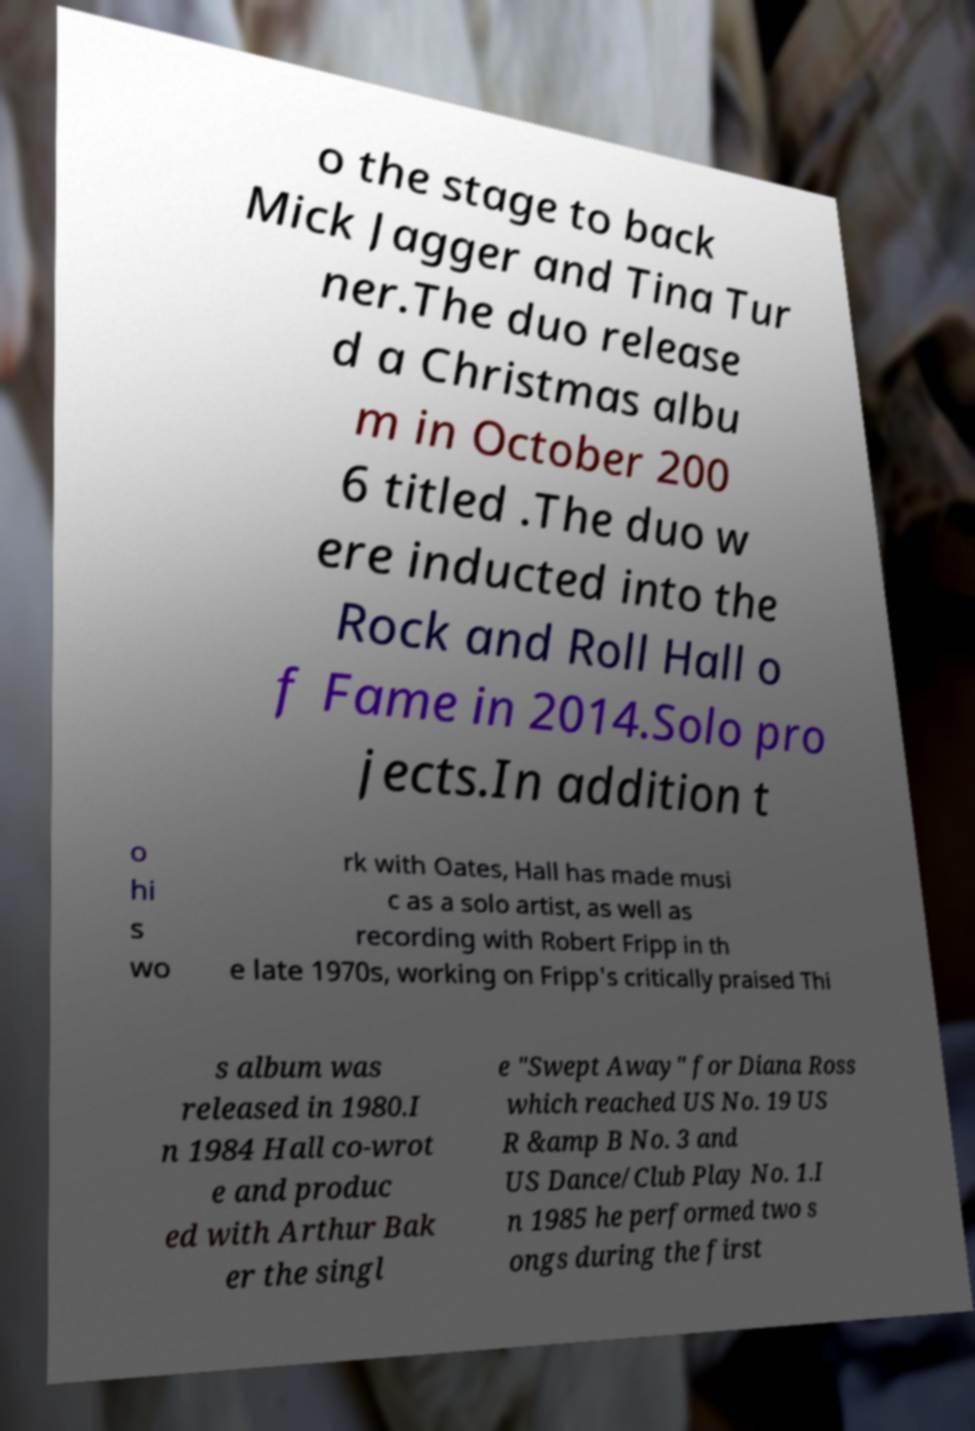Could you assist in decoding the text presented in this image and type it out clearly? o the stage to back Mick Jagger and Tina Tur ner.The duo release d a Christmas albu m in October 200 6 titled .The duo w ere inducted into the Rock and Roll Hall o f Fame in 2014.Solo pro jects.In addition t o hi s wo rk with Oates, Hall has made musi c as a solo artist, as well as recording with Robert Fripp in th e late 1970s, working on Fripp's critically praised Thi s album was released in 1980.I n 1984 Hall co-wrot e and produc ed with Arthur Bak er the singl e "Swept Away" for Diana Ross which reached US No. 19 US R &amp B No. 3 and US Dance/Club Play No. 1.I n 1985 he performed two s ongs during the first 